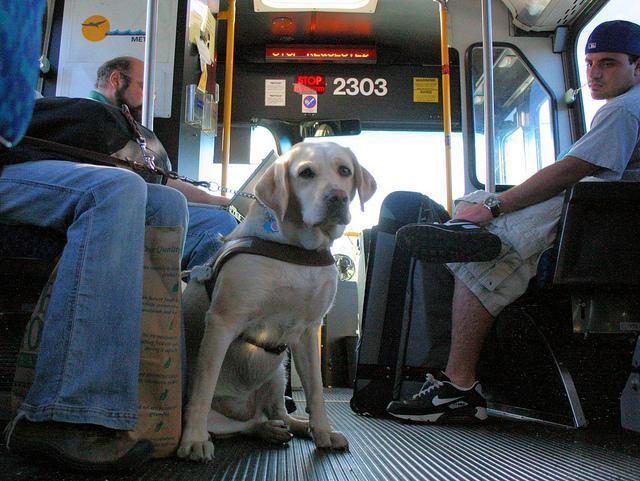How many dogs are on the bus?
Give a very brief answer. 1. How many people are there?
Give a very brief answer. 3. How many cars in the shot?
Give a very brief answer. 0. 